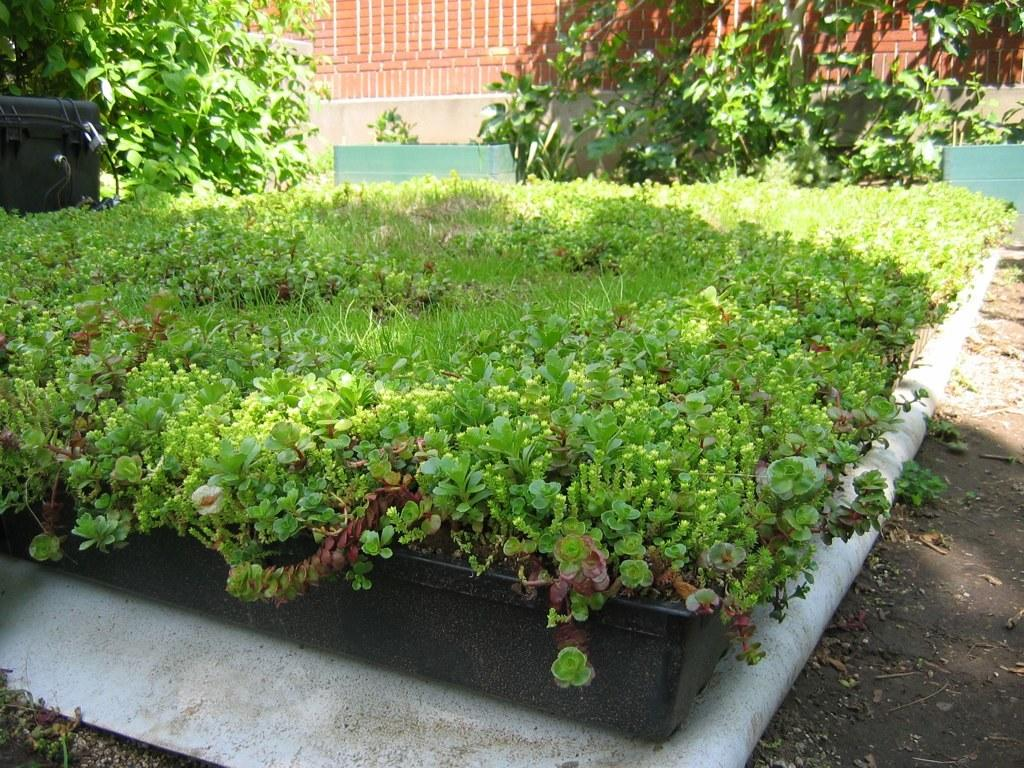What type of plants are in the container in the image? There is a group of plants in a container in the image. What other object can be seen in the image? There is a box in the image. Are there any other plants visible in the image? Yes, there are additional plants in the image. What is the background of the image? There is a wall in the image. Can you see the part of the plant that absorbs water in the image? The image does not show a specific part of the plant that absorbs water, but it does show the plants in a container. 